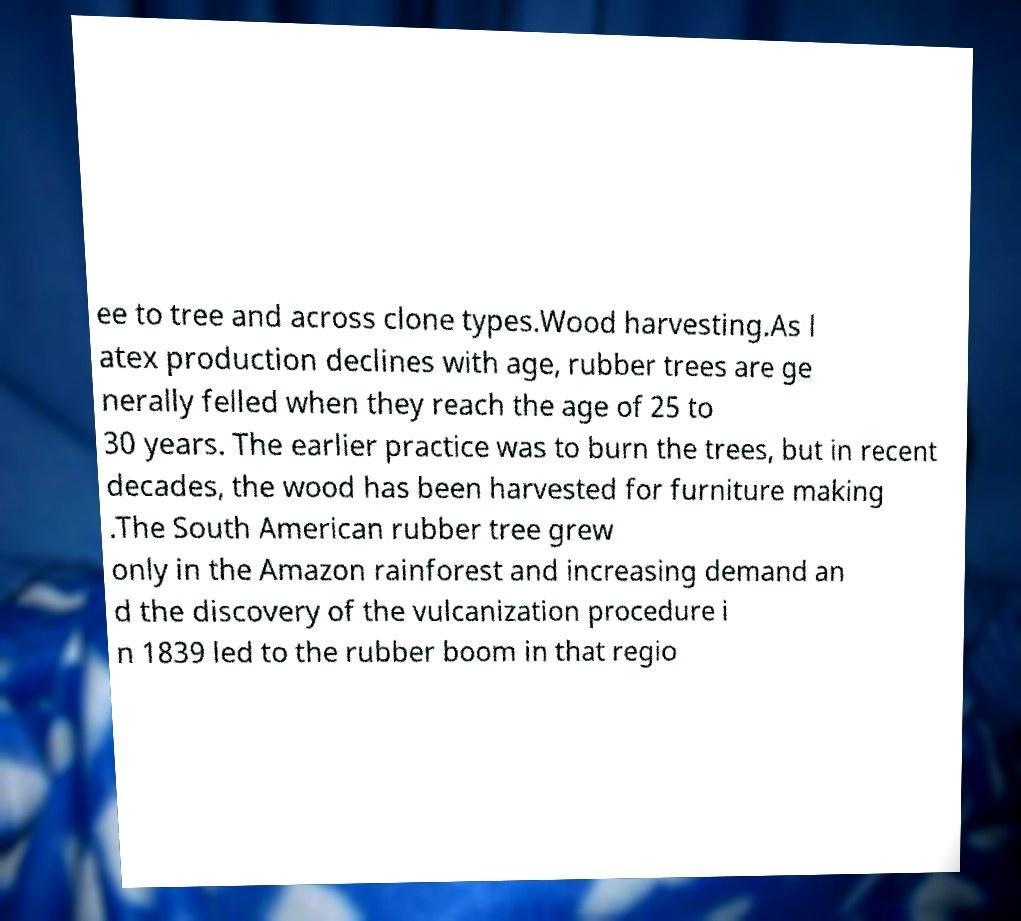Please read and relay the text visible in this image. What does it say? ee to tree and across clone types.Wood harvesting.As l atex production declines with age, rubber trees are ge nerally felled when they reach the age of 25 to 30 years. The earlier practice was to burn the trees, but in recent decades, the wood has been harvested for furniture making .The South American rubber tree grew only in the Amazon rainforest and increasing demand an d the discovery of the vulcanization procedure i n 1839 led to the rubber boom in that regio 